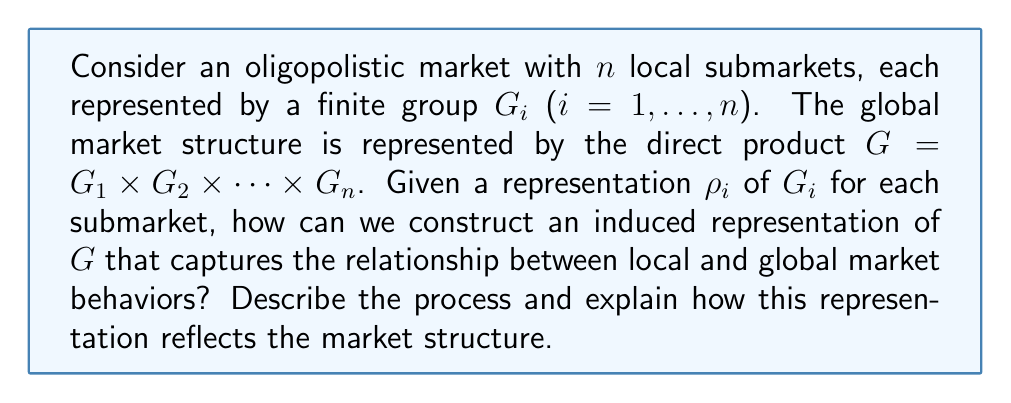Give your solution to this math problem. To solve this problem, we'll follow these steps:

1) First, we need to understand that each local submarket $G_i$ has its own representation $\rho_i$. These representations capture the behavior and dynamics of each local market.

2) To study the relationship between local and global markets, we need to construct a representation of the global market $G$ using the local market representations. This is where induced representations come into play.

3) For each local market $G_i$, we can view its representation $\rho_i$ as a representation of the global market $G$ by extending it trivially. Let's call this extended representation $\tilde{\rho}_i$. Mathematically:

   $$\tilde{\rho}_i(g_1,\ldots,g_n) = \rho_i(g_i)$$

   where $(g_1,\ldots,g_n) \in G$.

4) Now, we can construct the induced representation of $G$ by taking the tensor product of these extended representations:

   $$\text{Ind}_G(\rho_1,\ldots,\rho_n) = \tilde{\rho}_1 \otimes \tilde{\rho}_2 \otimes \cdots \otimes \tilde{\rho}_n$$

5) This induced representation has the following properties:
   - Its dimension is the product of the dimensions of the local representations: $\dim(\text{Ind}_G(\rho_1,\ldots,\rho_n)) = \prod_{i=1}^n \dim(\rho_i)$
   - It captures how changes in one local market affect the global market structure
   - It preserves the independence of local markets while allowing for interactions in the global context

6) The character of this induced representation is given by:

   $$\chi_{\text{Ind}_G(\rho_1,\ldots,\rho_n)}(g_1,\ldots,g_n) = \prod_{i=1}^n \chi_{\rho_i}(g_i)$$

   where $\chi_{\rho_i}$ is the character of the local representation $\rho_i$.

This induced representation reflects the market structure by:
- Preserving the local market behaviors through the individual representations $\rho_i$
- Capturing global market behavior through the tensor product structure
- Allowing analysis of how local market changes propagate to the global market
Answer: $\text{Ind}_G(\rho_1,\ldots,\rho_n) = \tilde{\rho}_1 \otimes \tilde{\rho}_2 \otimes \cdots \otimes \tilde{\rho}_n$ 